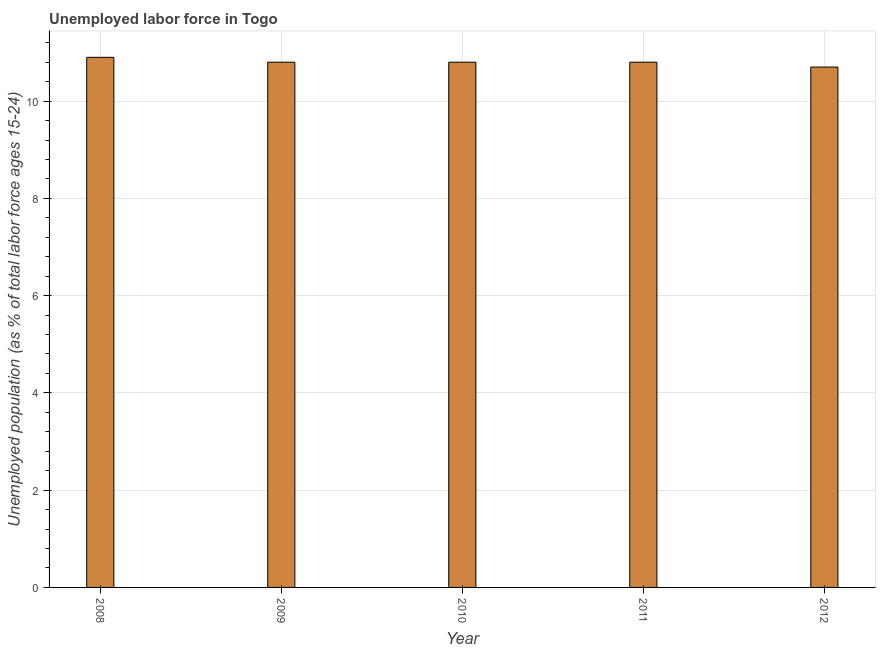What is the title of the graph?
Keep it short and to the point. Unemployed labor force in Togo. What is the label or title of the X-axis?
Your response must be concise. Year. What is the label or title of the Y-axis?
Keep it short and to the point. Unemployed population (as % of total labor force ages 15-24). What is the total unemployed youth population in 2009?
Give a very brief answer. 10.8. Across all years, what is the maximum total unemployed youth population?
Keep it short and to the point. 10.9. Across all years, what is the minimum total unemployed youth population?
Ensure brevity in your answer.  10.7. What is the sum of the total unemployed youth population?
Give a very brief answer. 54. What is the average total unemployed youth population per year?
Make the answer very short. 10.8. What is the median total unemployed youth population?
Make the answer very short. 10.8. In how many years, is the total unemployed youth population greater than 10 %?
Provide a short and direct response. 5. What is the ratio of the total unemployed youth population in 2011 to that in 2012?
Ensure brevity in your answer.  1.01. Is the difference between the total unemployed youth population in 2009 and 2012 greater than the difference between any two years?
Offer a very short reply. No. What is the difference between the highest and the second highest total unemployed youth population?
Provide a succinct answer. 0.1. In how many years, is the total unemployed youth population greater than the average total unemployed youth population taken over all years?
Give a very brief answer. 4. How many bars are there?
Your response must be concise. 5. Are all the bars in the graph horizontal?
Provide a succinct answer. No. How many years are there in the graph?
Your answer should be compact. 5. Are the values on the major ticks of Y-axis written in scientific E-notation?
Your response must be concise. No. What is the Unemployed population (as % of total labor force ages 15-24) in 2008?
Provide a short and direct response. 10.9. What is the Unemployed population (as % of total labor force ages 15-24) of 2009?
Ensure brevity in your answer.  10.8. What is the Unemployed population (as % of total labor force ages 15-24) in 2010?
Ensure brevity in your answer.  10.8. What is the Unemployed population (as % of total labor force ages 15-24) in 2011?
Offer a terse response. 10.8. What is the Unemployed population (as % of total labor force ages 15-24) of 2012?
Offer a terse response. 10.7. What is the difference between the Unemployed population (as % of total labor force ages 15-24) in 2008 and 2010?
Keep it short and to the point. 0.1. What is the difference between the Unemployed population (as % of total labor force ages 15-24) in 2008 and 2011?
Your answer should be very brief. 0.1. What is the difference between the Unemployed population (as % of total labor force ages 15-24) in 2008 and 2012?
Offer a very short reply. 0.2. What is the difference between the Unemployed population (as % of total labor force ages 15-24) in 2009 and 2010?
Make the answer very short. 0. What is the ratio of the Unemployed population (as % of total labor force ages 15-24) in 2009 to that in 2012?
Give a very brief answer. 1.01. What is the ratio of the Unemployed population (as % of total labor force ages 15-24) in 2011 to that in 2012?
Provide a succinct answer. 1.01. 